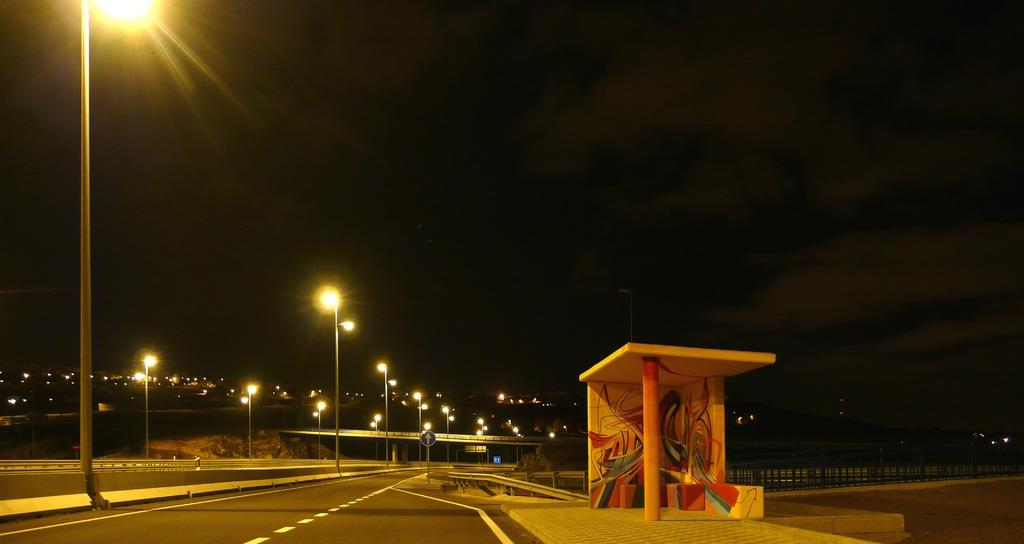What type of pathway is visible in the image? There is a road in the image. What structure can be seen near the road? There is a fence in the image. What are the vertical supports in the image? There are poles in the image. What illuminates the area in the image? There are lights in the image. What type of structure is present over a body of water in the image? There is a bridge in the image. What are the large, solid supports in the image? There are pillars in the image. What type of shelter is visible in the image? There is a shelter in the image. What flat, rectangular objects are present in the image? There are boards in the image. What can be seen in the background of the image? The sky is visible in the background of the image. What riddle is being solved by the sun in the image? There is no riddle being solved by the sun in the image, as the sun is not present. What activity are the boards participating in the image? The boards are not participating in any activity; they are simply flat, rectangular objects in the image. 